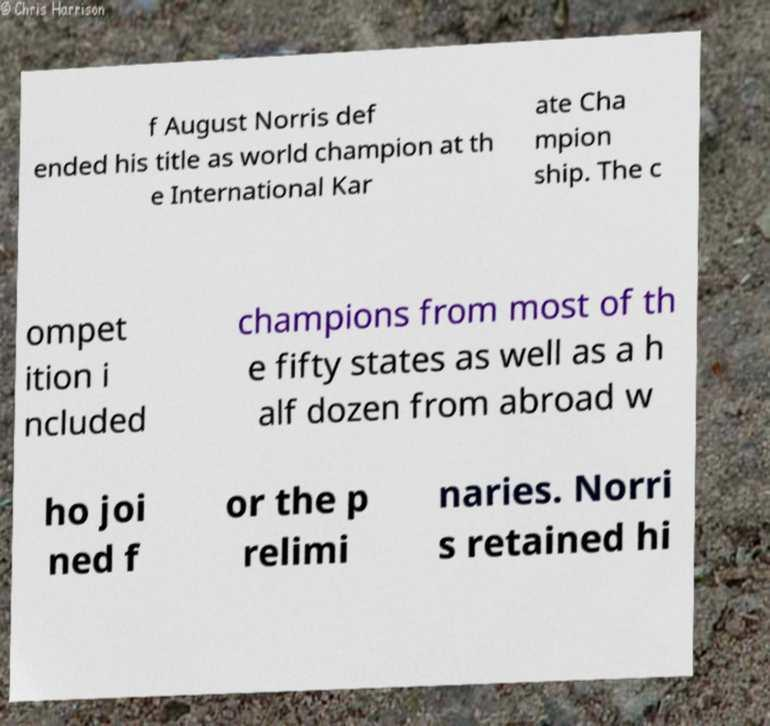Please identify and transcribe the text found in this image. f August Norris def ended his title as world champion at th e International Kar ate Cha mpion ship. The c ompet ition i ncluded champions from most of th e fifty states as well as a h alf dozen from abroad w ho joi ned f or the p relimi naries. Norri s retained hi 